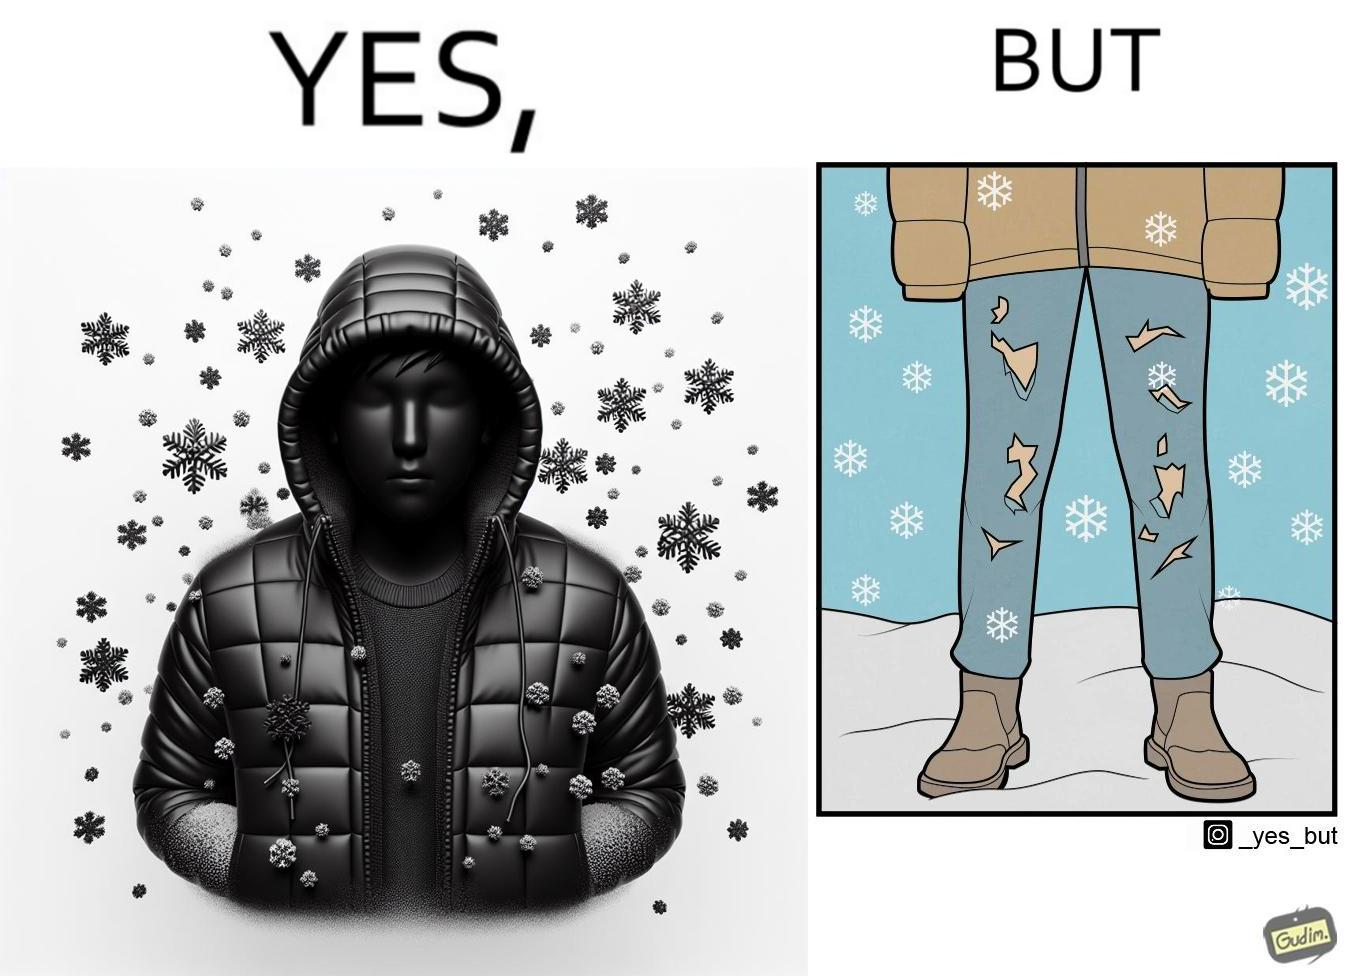Provide a description of this image. This is funny because on the one hand this person is feeling very cold and has his jacket all the way up to his face, but on the other hand his trousers are torn which kind of makes the jacket redundant. 